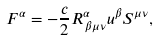<formula> <loc_0><loc_0><loc_500><loc_500>F ^ { \alpha } = - \frac { c } { 2 } R ^ { \alpha } _ { \, \beta \mu \nu } u ^ { \beta } S ^ { \mu \nu } ,</formula> 